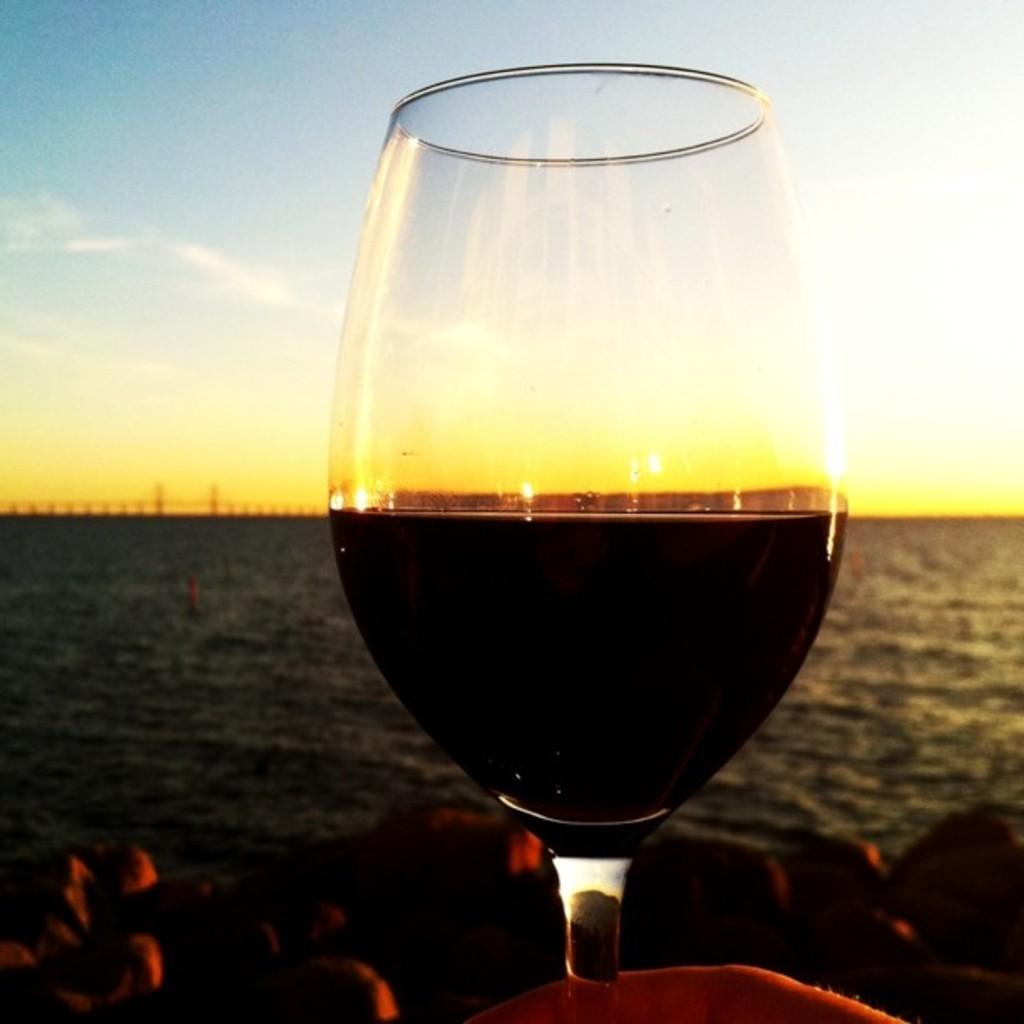What object is present in the image that can hold a liquid? There is a glass in the image that can hold a liquid. What liquid can be seen in the image? There is water visible in the image. How would you describe the color of the sky in the image? The sky is blue, white, and yellow in color. What type of cake is being served in the image? There is no cake present in the image. What action is taking place in the image? The image does not depict any specific action or event. 